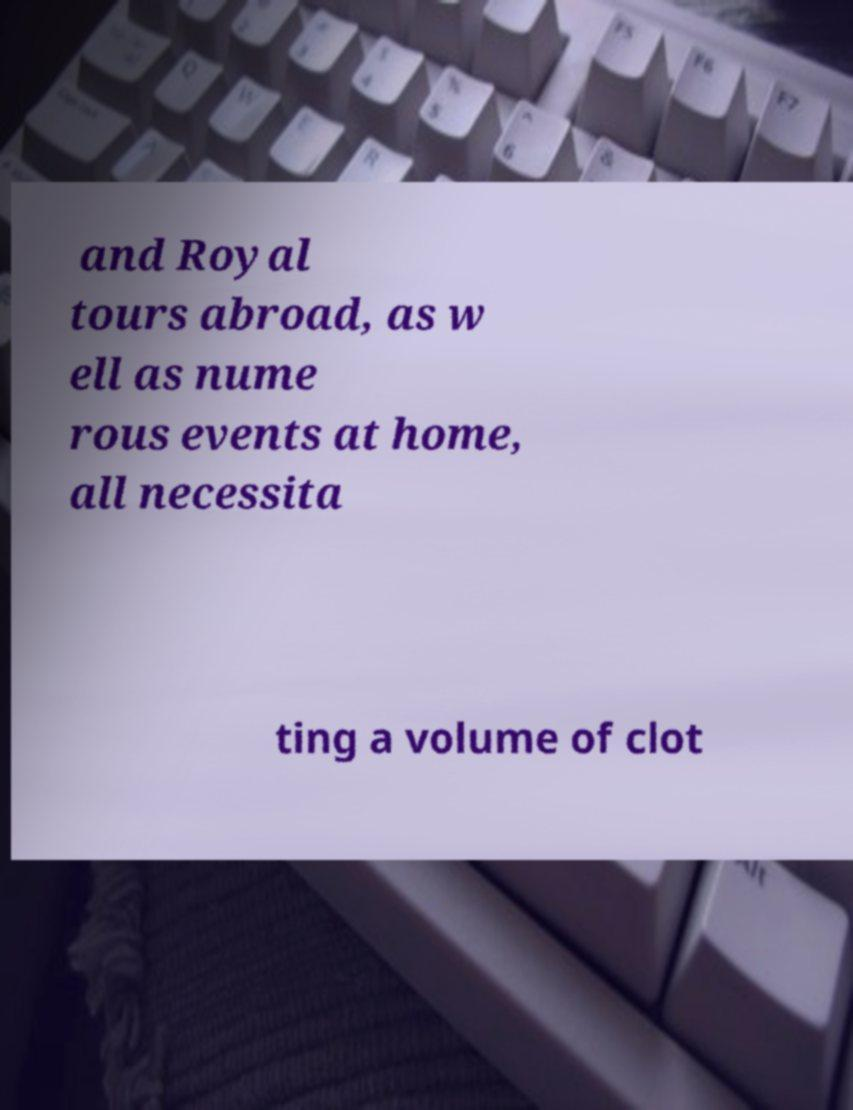Can you accurately transcribe the text from the provided image for me? and Royal tours abroad, as w ell as nume rous events at home, all necessita ting a volume of clot 